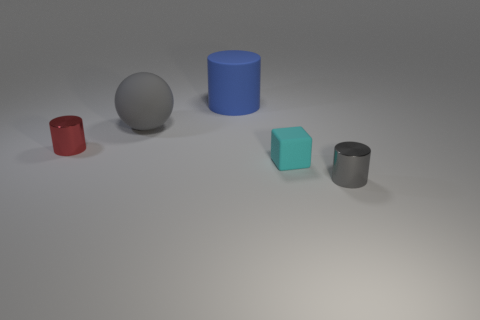Subtract all red cylinders. Subtract all yellow balls. How many cylinders are left? 2 Add 3 gray cylinders. How many objects exist? 8 Subtract all blocks. How many objects are left? 4 Subtract all large gray objects. Subtract all green metal cylinders. How many objects are left? 4 Add 4 large rubber things. How many large rubber things are left? 6 Add 4 gray cylinders. How many gray cylinders exist? 5 Subtract 1 gray spheres. How many objects are left? 4 